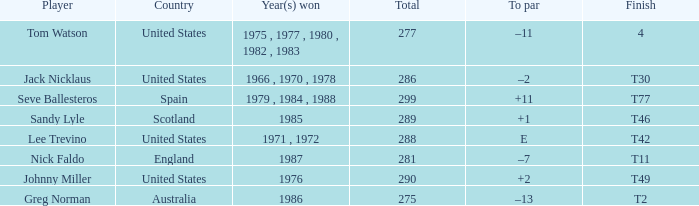What's england's to par? –7. 